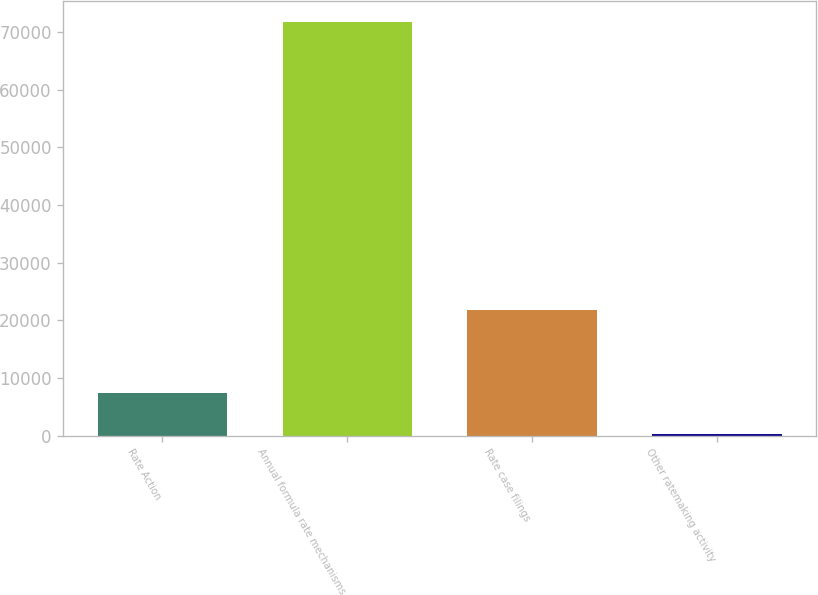Convert chart to OTSL. <chart><loc_0><loc_0><loc_500><loc_500><bar_chart><fcel>Rate Action<fcel>Annual formula rate mechanisms<fcel>Rate case filings<fcel>Other ratemaking activity<nl><fcel>7378.3<fcel>71749<fcel>21819<fcel>226<nl></chart> 